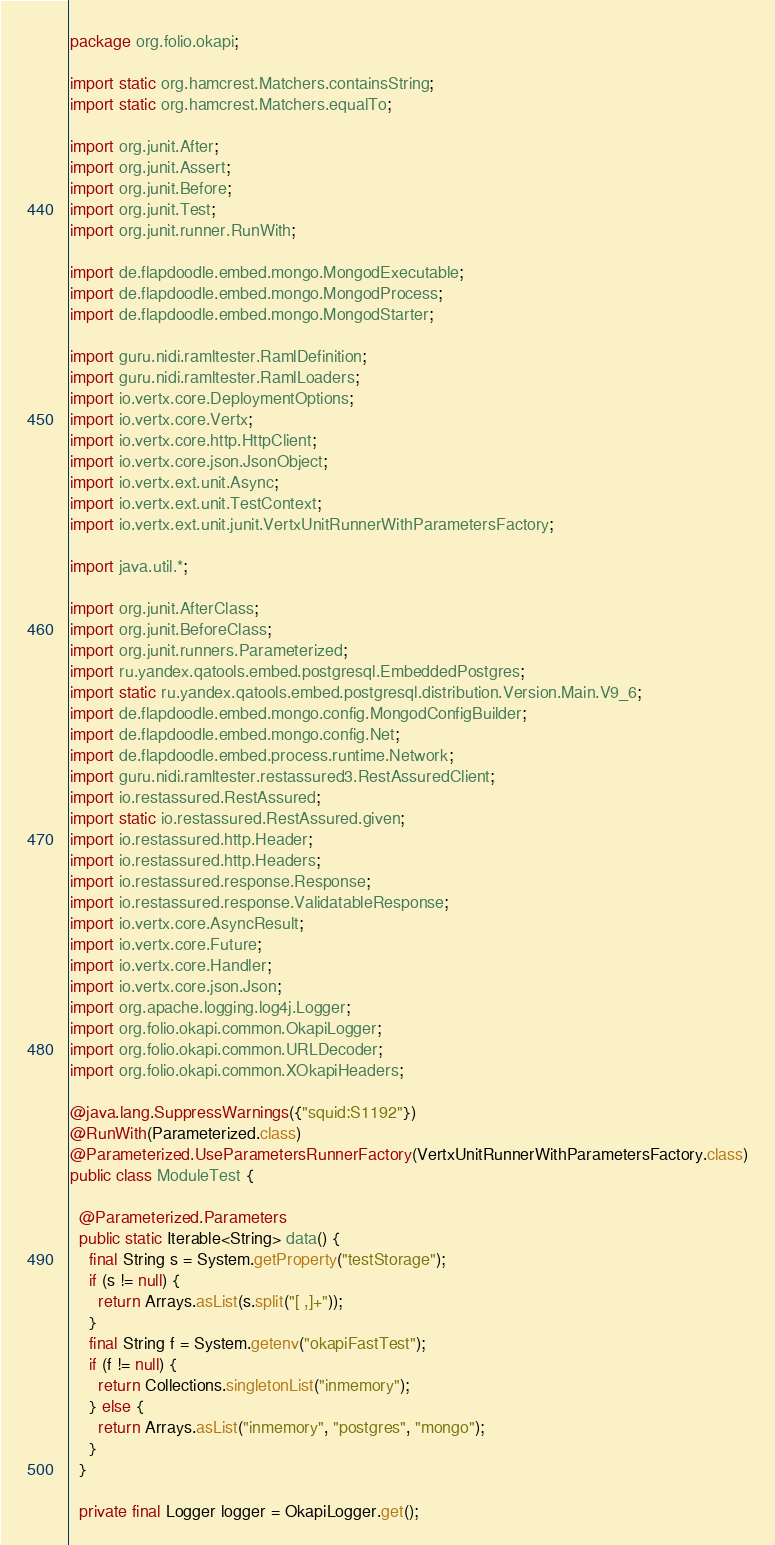<code> <loc_0><loc_0><loc_500><loc_500><_Java_>package org.folio.okapi;

import static org.hamcrest.Matchers.containsString;
import static org.hamcrest.Matchers.equalTo;

import org.junit.After;
import org.junit.Assert;
import org.junit.Before;
import org.junit.Test;
import org.junit.runner.RunWith;

import de.flapdoodle.embed.mongo.MongodExecutable;
import de.flapdoodle.embed.mongo.MongodProcess;
import de.flapdoodle.embed.mongo.MongodStarter;

import guru.nidi.ramltester.RamlDefinition;
import guru.nidi.ramltester.RamlLoaders;
import io.vertx.core.DeploymentOptions;
import io.vertx.core.Vertx;
import io.vertx.core.http.HttpClient;
import io.vertx.core.json.JsonObject;
import io.vertx.ext.unit.Async;
import io.vertx.ext.unit.TestContext;
import io.vertx.ext.unit.junit.VertxUnitRunnerWithParametersFactory;

import java.util.*;

import org.junit.AfterClass;
import org.junit.BeforeClass;
import org.junit.runners.Parameterized;
import ru.yandex.qatools.embed.postgresql.EmbeddedPostgres;
import static ru.yandex.qatools.embed.postgresql.distribution.Version.Main.V9_6;
import de.flapdoodle.embed.mongo.config.MongodConfigBuilder;
import de.flapdoodle.embed.mongo.config.Net;
import de.flapdoodle.embed.process.runtime.Network;
import guru.nidi.ramltester.restassured3.RestAssuredClient;
import io.restassured.RestAssured;
import static io.restassured.RestAssured.given;
import io.restassured.http.Header;
import io.restassured.http.Headers;
import io.restassured.response.Response;
import io.restassured.response.ValidatableResponse;
import io.vertx.core.AsyncResult;
import io.vertx.core.Future;
import io.vertx.core.Handler;
import io.vertx.core.json.Json;
import org.apache.logging.log4j.Logger;
import org.folio.okapi.common.OkapiLogger;
import org.folio.okapi.common.URLDecoder;
import org.folio.okapi.common.XOkapiHeaders;

@java.lang.SuppressWarnings({"squid:S1192"})
@RunWith(Parameterized.class)
@Parameterized.UseParametersRunnerFactory(VertxUnitRunnerWithParametersFactory.class)
public class ModuleTest {

  @Parameterized.Parameters
  public static Iterable<String> data() {
    final String s = System.getProperty("testStorage");
    if (s != null) {
      return Arrays.asList(s.split("[ ,]+"));
    }
    final String f = System.getenv("okapiFastTest");
    if (f != null) {
      return Collections.singletonList("inmemory");
    } else {
      return Arrays.asList("inmemory", "postgres", "mongo");
    }
  }

  private final Logger logger = OkapiLogger.get();
</code> 